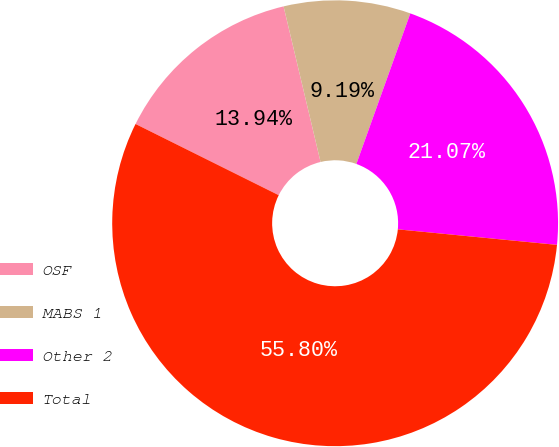Convert chart. <chart><loc_0><loc_0><loc_500><loc_500><pie_chart><fcel>OSF<fcel>MABS 1<fcel>Other 2<fcel>Total<nl><fcel>13.94%<fcel>9.19%<fcel>21.07%<fcel>55.8%<nl></chart> 